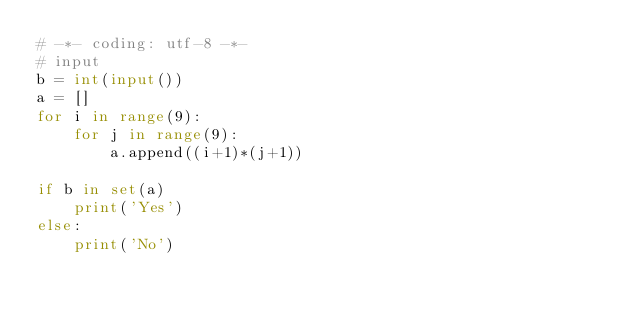Convert code to text. <code><loc_0><loc_0><loc_500><loc_500><_Python_># -*- coding: utf-8 -*-
# input
b = int(input())
a = []
for i in range(9):
    for j in range(9):
        a.append((i+1)*(j+1))

if b in set(a)
    print('Yes')
else:
    print('No')</code> 